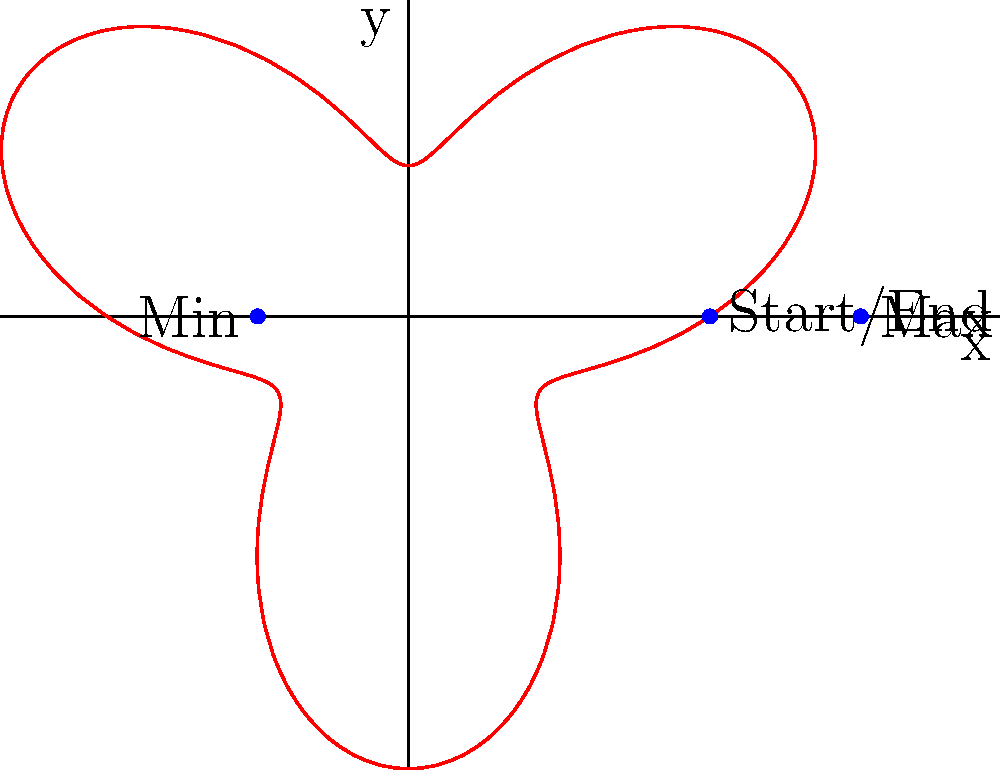In a virtual reality slot machine game, the trajectory of the arm pull is modeled by the polar equation $r = 2 + \sin(3\theta)$, where $r$ is in virtual units and $\theta$ is in radians. What is the maximum distance the arm travels from the origin during a complete pull cycle? To find the maximum distance the arm travels from the origin, we need to follow these steps:

1) The given polar equation is $r = 2 + \sin(3\theta)$.

2) The maximum value of $\sin(3\theta)$ is 1, which occurs when $3\theta = \frac{\pi}{2}, \frac{5\pi}{2}, \frac{9\pi}{2}$, etc.

3) When $\sin(3\theta) = 1$, the equation becomes:
   $r_{max} = 2 + 1 = 3$

4) Therefore, the maximum distance from the origin is 3 virtual units.

5) We can verify this by looking at the graph, where the outermost point of the curve touches the x-axis at (3,0).

This maximum distance represents the farthest point the virtual arm reaches during its pull cycle, creating an immersive and realistic slot machine experience in the VR environment.
Answer: 3 virtual units 